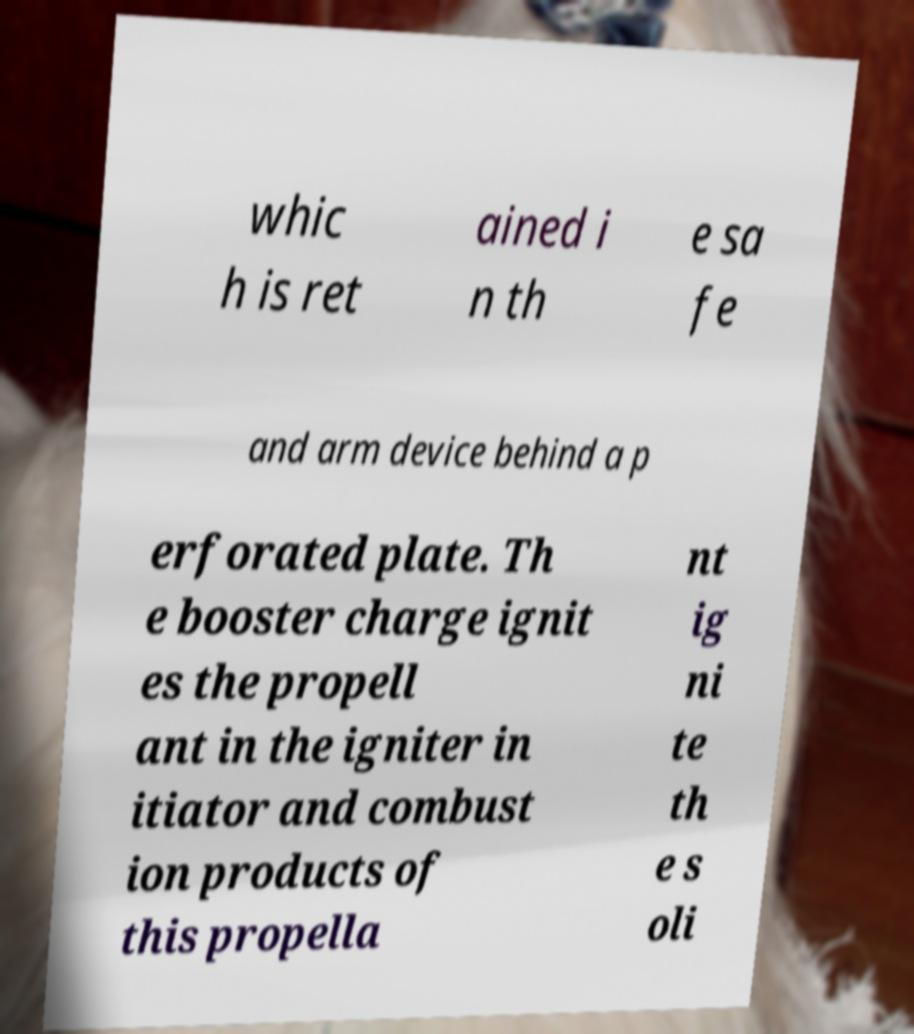Can you accurately transcribe the text from the provided image for me? whic h is ret ained i n th e sa fe and arm device behind a p erforated plate. Th e booster charge ignit es the propell ant in the igniter in itiator and combust ion products of this propella nt ig ni te th e s oli 